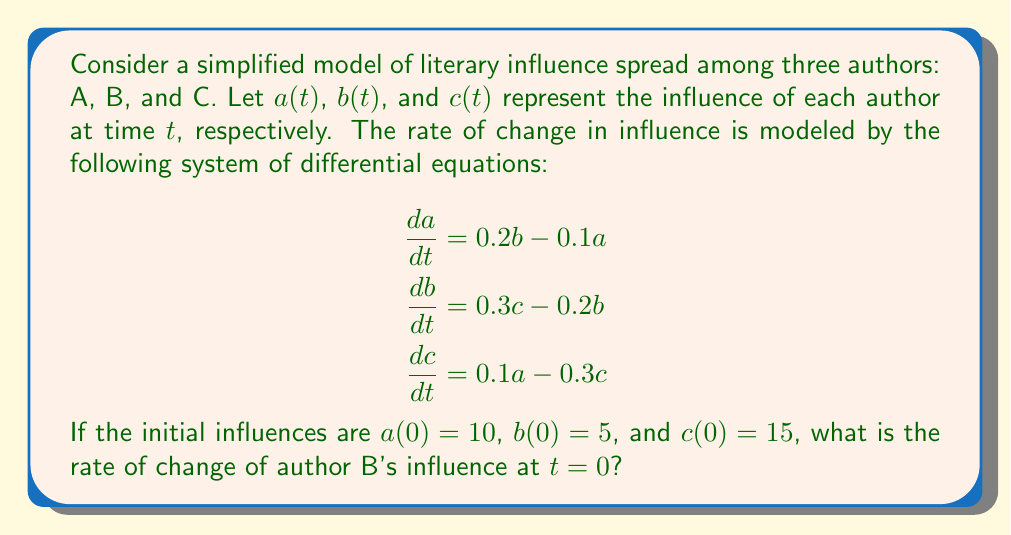Provide a solution to this math problem. To solve this problem, we need to follow these steps:

1. Identify the equation for the rate of change of author B's influence:
   $$\frac{db}{dt} = 0.3c - 0.2b$$

2. We need to evaluate this equation at $t = 0$ using the given initial conditions:
   $a(0) = 10$, $b(0) = 5$, and $c(0) = 15$

3. Substitute the values into the equation:
   $$\frac{db}{dt}\bigg|_{t=0} = 0.3c(0) - 0.2b(0)$$

4. Replace $c(0)$ and $b(0)$ with their given values:
   $$\frac{db}{dt}\bigg|_{t=0} = 0.3(15) - 0.2(5)$$

5. Calculate the result:
   $$\frac{db}{dt}\bigg|_{t=0} = 4.5 - 1 = 3.5$$

Therefore, the rate of change of author B's influence at $t = 0$ is 3.5 units per time unit.
Answer: 3.5 